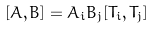<formula> <loc_0><loc_0><loc_500><loc_500>[ A , B ] = A _ { i } B _ { j } [ T _ { i } , T _ { j } ]</formula> 